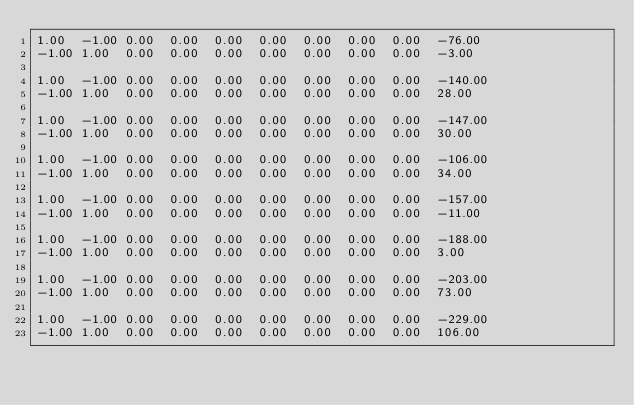<code> <loc_0><loc_0><loc_500><loc_500><_Matlab_>1.00	-1.00	0.00	0.00	0.00	0.00	0.00	0.00	0.00	-76.00
-1.00	1.00	0.00	0.00	0.00	0.00	0.00	0.00	0.00	-3.00

1.00	-1.00	0.00	0.00	0.00	0.00	0.00	0.00	0.00	-140.00
-1.00	1.00	0.00	0.00	0.00	0.00	0.00	0.00	0.00	28.00

1.00	-1.00	0.00	0.00	0.00	0.00	0.00	0.00	0.00	-147.00
-1.00	1.00	0.00	0.00	0.00	0.00	0.00	0.00	0.00	30.00

1.00	-1.00	0.00	0.00	0.00	0.00	0.00	0.00	0.00	-106.00
-1.00	1.00	0.00	0.00	0.00	0.00	0.00	0.00	0.00	34.00

1.00	-1.00	0.00	0.00	0.00	0.00	0.00	0.00	0.00	-157.00
-1.00	1.00	0.00	0.00	0.00	0.00	0.00	0.00	0.00	-11.00

1.00	-1.00	0.00	0.00	0.00	0.00	0.00	0.00	0.00	-188.00
-1.00	1.00	0.00	0.00	0.00	0.00	0.00	0.00	0.00	3.00

1.00	-1.00	0.00	0.00	0.00	0.00	0.00	0.00	0.00	-203.00
-1.00	1.00	0.00	0.00	0.00	0.00	0.00	0.00	0.00	73.00

1.00	-1.00	0.00	0.00	0.00	0.00	0.00	0.00	0.00	-229.00
-1.00	1.00	0.00	0.00	0.00	0.00	0.00	0.00	0.00	106.00
</code> 